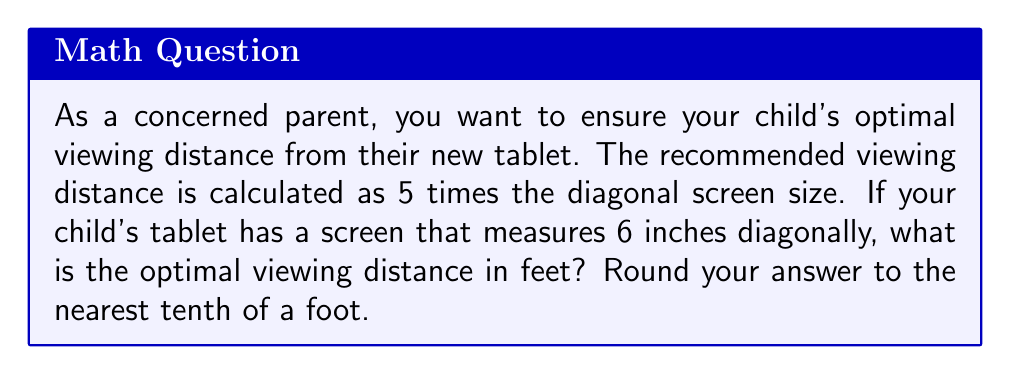Could you help me with this problem? To solve this problem, we'll follow these steps:

1) First, let's recall the given information:
   - The optimal viewing distance is 5 times the diagonal screen size
   - The tablet's screen measures 6 inches diagonally

2) We can express this relationship mathematically:
   $$ \text{Optimal Distance} = 5 \times \text{Screen Size} $$

3) Let's plug in our known value:
   $$ \text{Optimal Distance} = 5 \times 6 \text{ inches} = 30 \text{ inches} $$

4) However, we need to convert this to feet. We know that 1 foot = 12 inches. So:
   $$ \text{Optimal Distance in feet} = \frac{30 \text{ inches}}{12 \text{ inches/foot}} = 2.5 \text{ feet} $$

5) The question asks to round to the nearest tenth of a foot, but 2.5 is already in this form.

Therefore, the optimal viewing distance is 2.5 feet.
Answer: 2.5 feet 